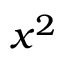Convert formula to latex. <formula><loc_0><loc_0><loc_500><loc_500>x ^ { 2 }</formula> 